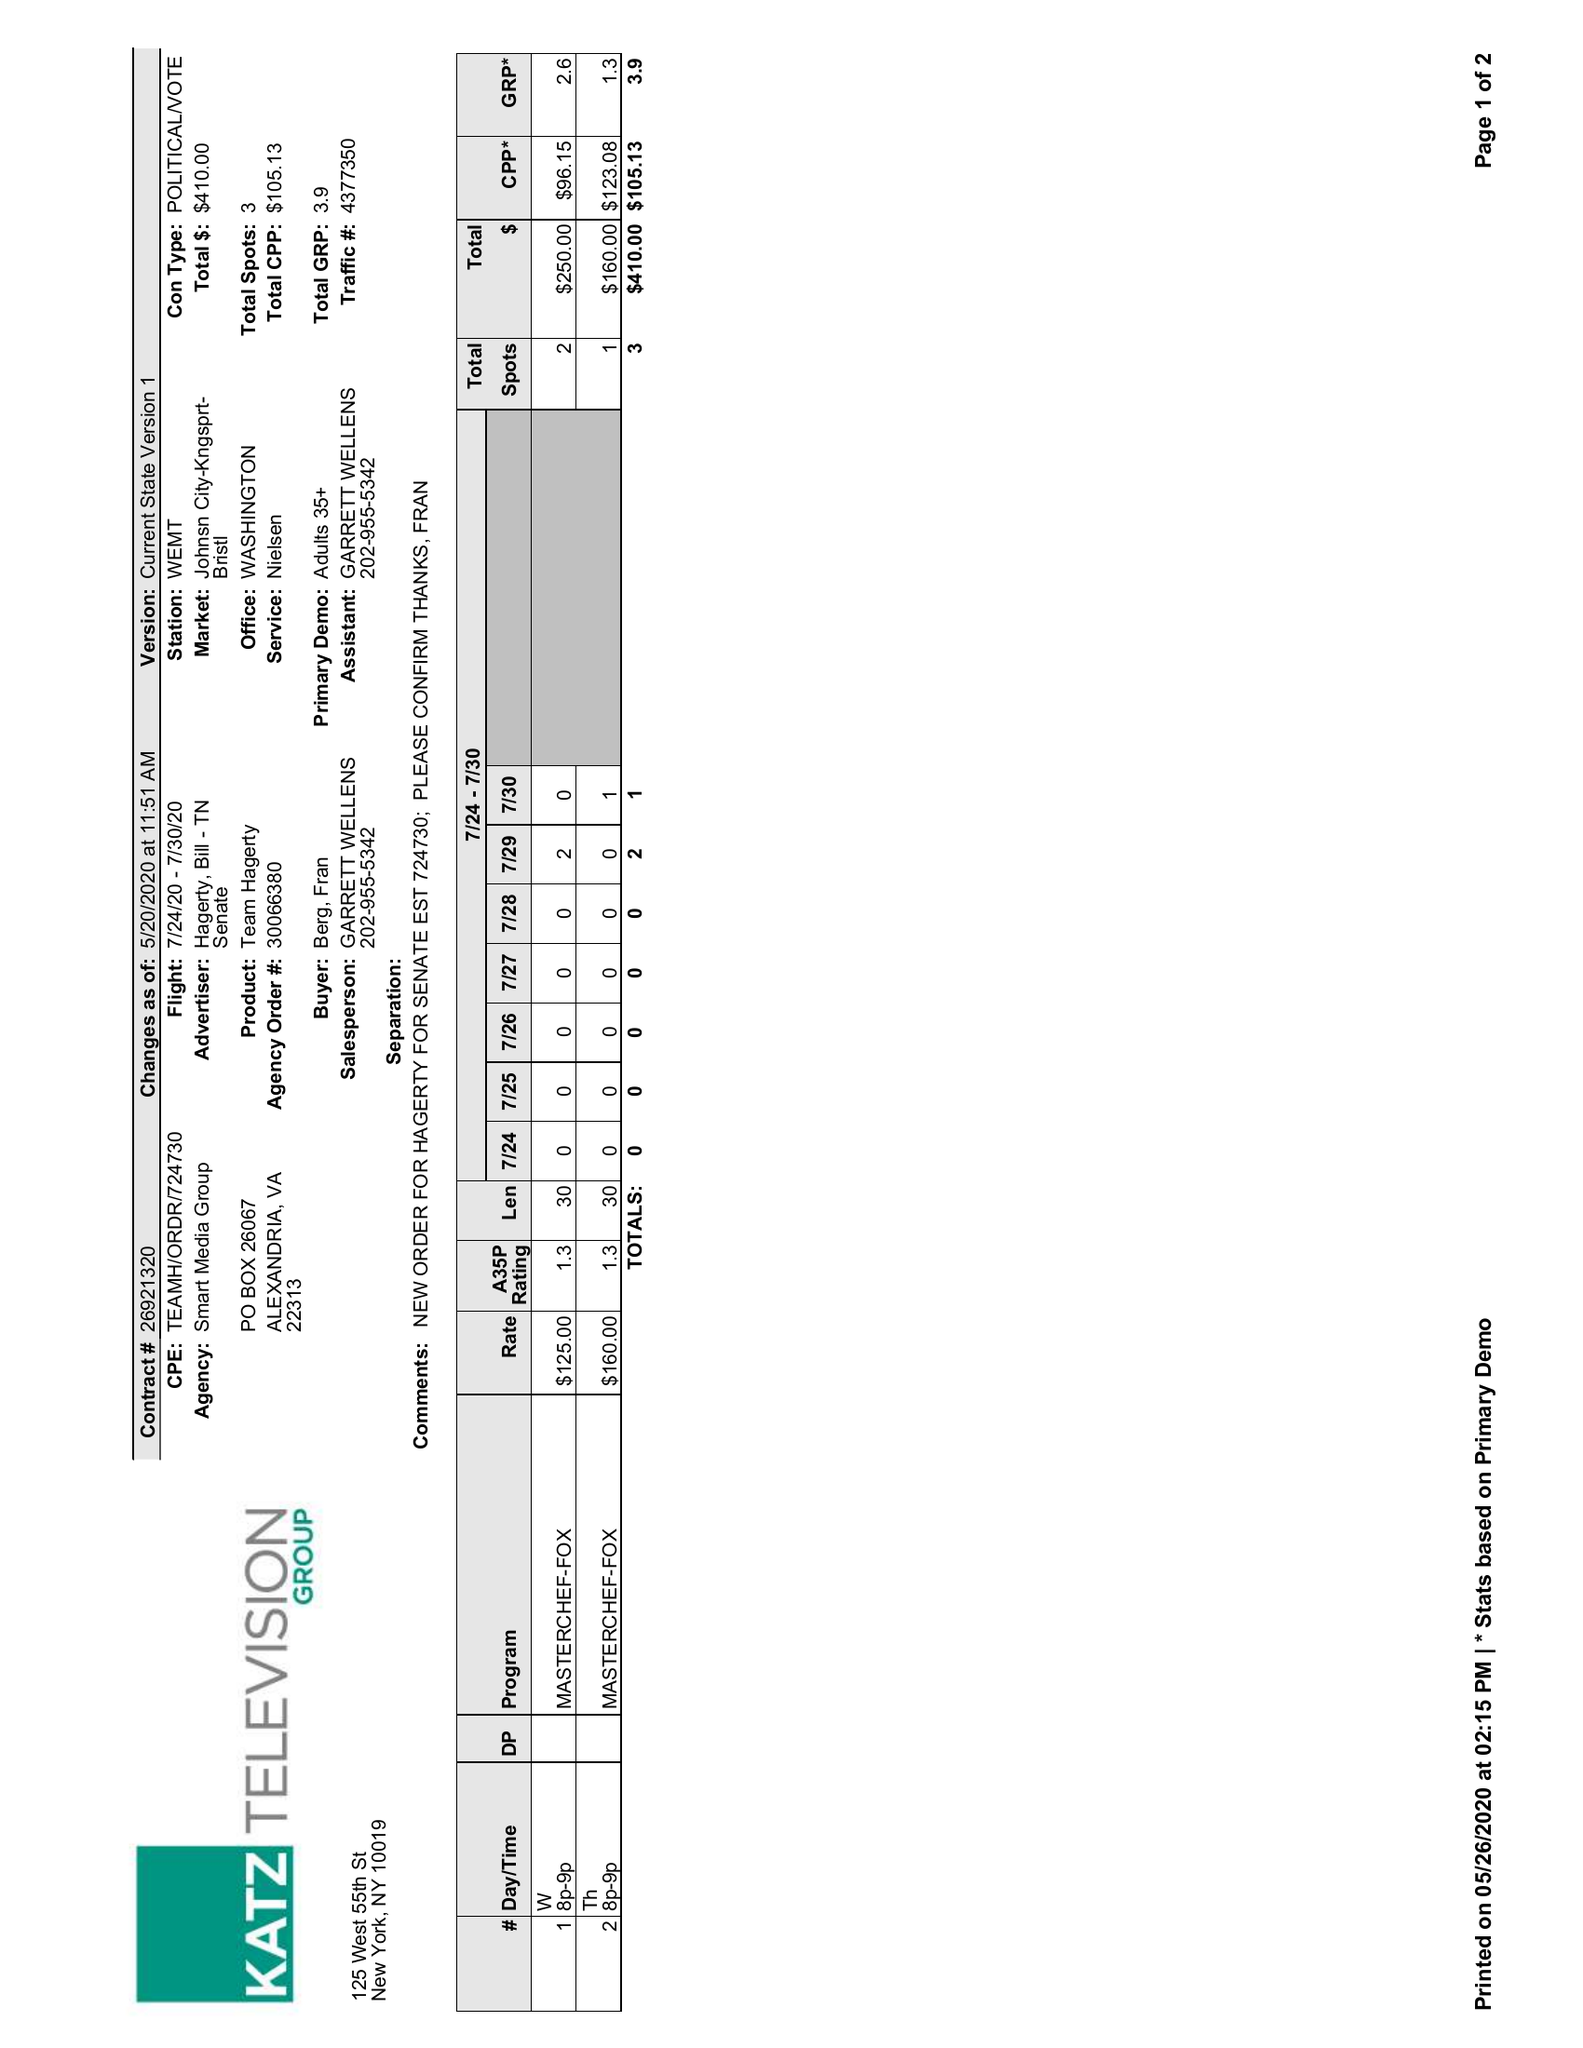What is the value for the advertiser?
Answer the question using a single word or phrase. HAGERTY, BILL - TN SENATE 